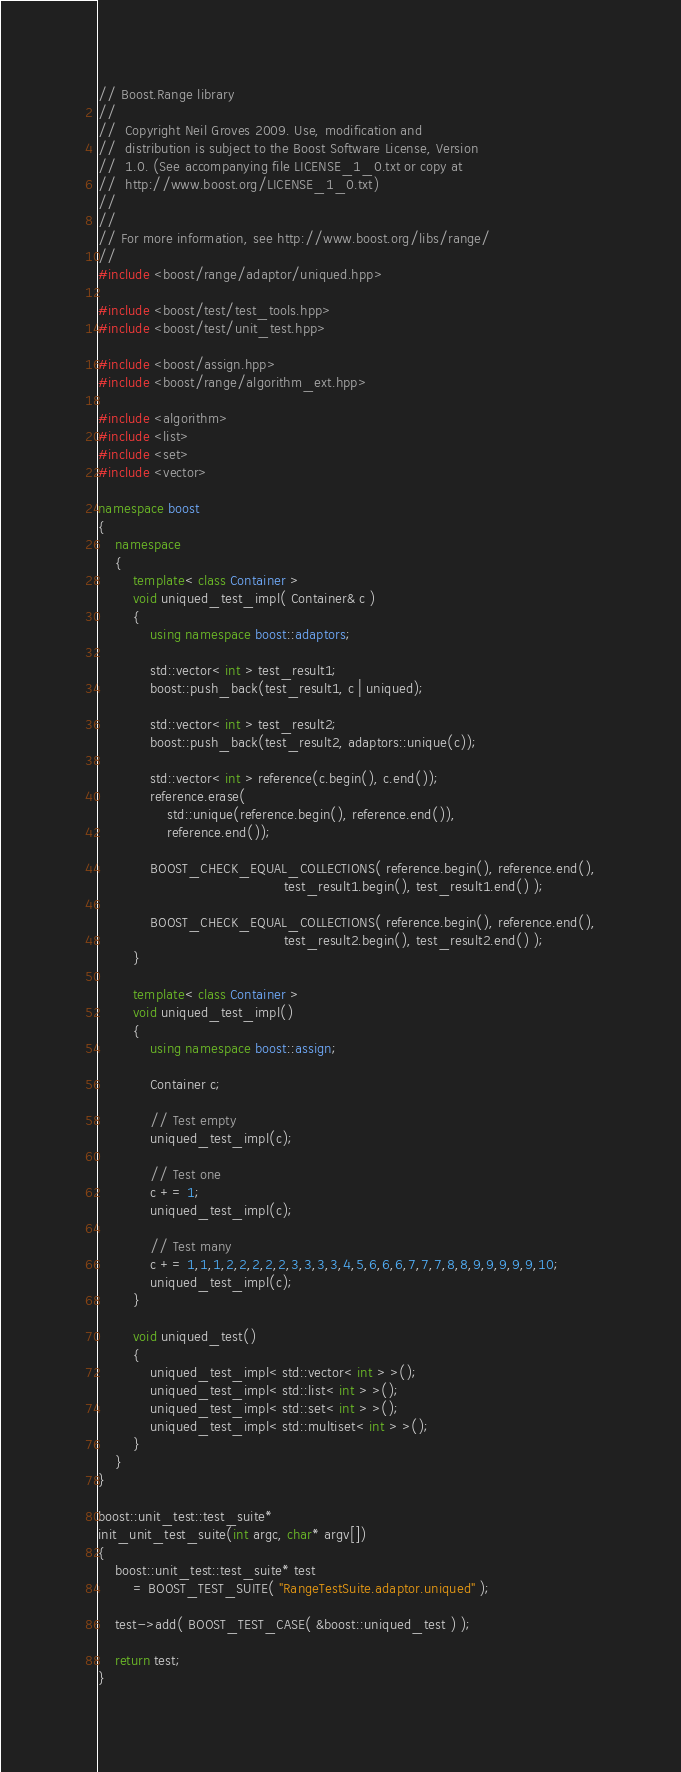Convert code to text. <code><loc_0><loc_0><loc_500><loc_500><_C++_>// Boost.Range library
//
//  Copyright Neil Groves 2009. Use, modification and
//  distribution is subject to the Boost Software License, Version
//  1.0. (See accompanying file LICENSE_1_0.txt or copy at
//  http://www.boost.org/LICENSE_1_0.txt)
//
//
// For more information, see http://www.boost.org/libs/range/
//
#include <boost/range/adaptor/uniqued.hpp>

#include <boost/test/test_tools.hpp>
#include <boost/test/unit_test.hpp>

#include <boost/assign.hpp>
#include <boost/range/algorithm_ext.hpp>

#include <algorithm>
#include <list>
#include <set>
#include <vector>

namespace boost
{
    namespace
    {
        template< class Container >
        void uniqued_test_impl( Container& c )
        {
            using namespace boost::adaptors;

            std::vector< int > test_result1;
            boost::push_back(test_result1, c | uniqued);

            std::vector< int > test_result2;
            boost::push_back(test_result2, adaptors::unique(c));

            std::vector< int > reference(c.begin(), c.end());
            reference.erase(
                std::unique(reference.begin(), reference.end()),
                reference.end());

            BOOST_CHECK_EQUAL_COLLECTIONS( reference.begin(), reference.end(),
                                           test_result1.begin(), test_result1.end() );

            BOOST_CHECK_EQUAL_COLLECTIONS( reference.begin(), reference.end(),
                                           test_result2.begin(), test_result2.end() );
        }

        template< class Container >
        void uniqued_test_impl()
        {
            using namespace boost::assign;

            Container c;

            // Test empty
            uniqued_test_impl(c);

            // Test one
            c += 1;
            uniqued_test_impl(c);

            // Test many
            c += 1,1,1,2,2,2,2,2,3,3,3,3,4,5,6,6,6,7,7,7,8,8,9,9,9,9,9,10;
            uniqued_test_impl(c);
        }

        void uniqued_test()
        {
            uniqued_test_impl< std::vector< int > >();
            uniqued_test_impl< std::list< int > >();
            uniqued_test_impl< std::set< int > >();
            uniqued_test_impl< std::multiset< int > >();
        }
    }
}

boost::unit_test::test_suite*
init_unit_test_suite(int argc, char* argv[])
{
    boost::unit_test::test_suite* test
        = BOOST_TEST_SUITE( "RangeTestSuite.adaptor.uniqued" );

    test->add( BOOST_TEST_CASE( &boost::uniqued_test ) );

    return test;
}
</code> 